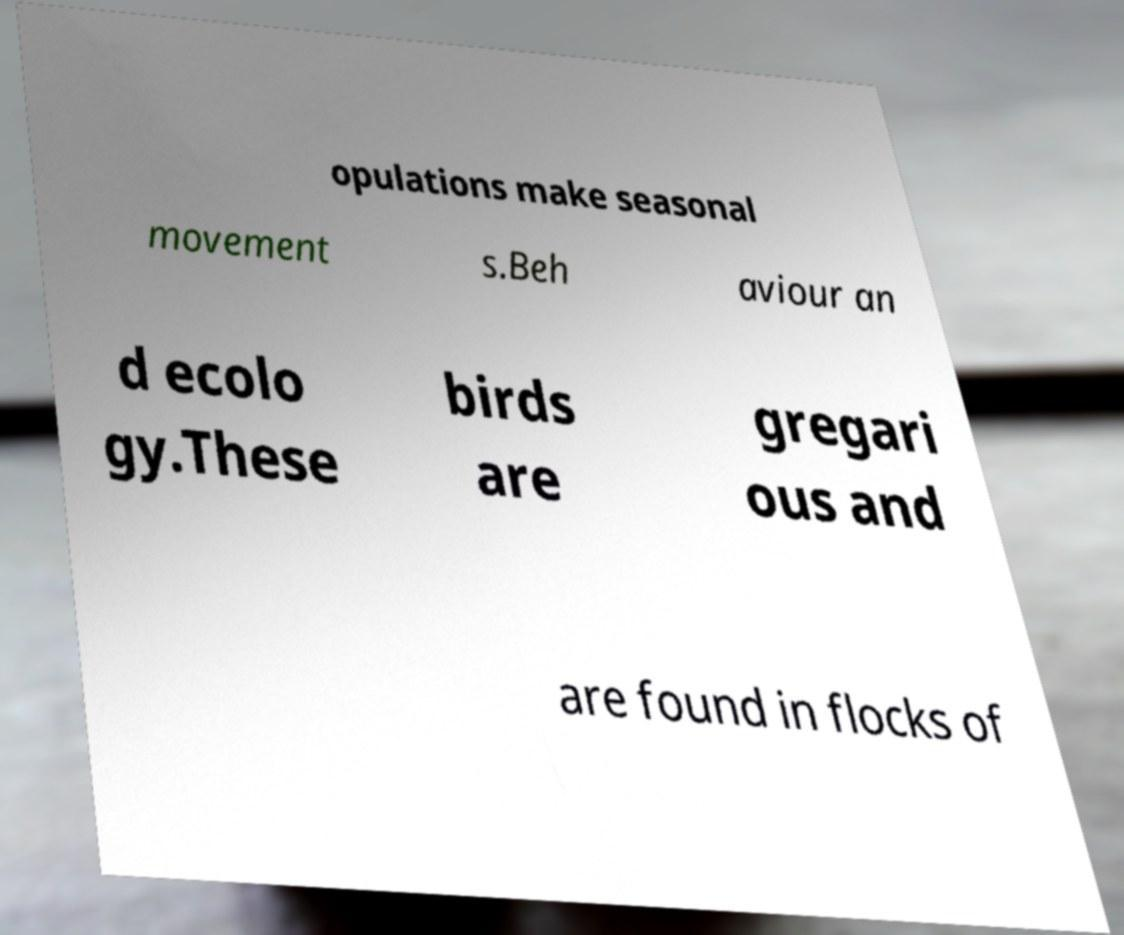Could you assist in decoding the text presented in this image and type it out clearly? opulations make seasonal movement s.Beh aviour an d ecolo gy.These birds are gregari ous and are found in flocks of 